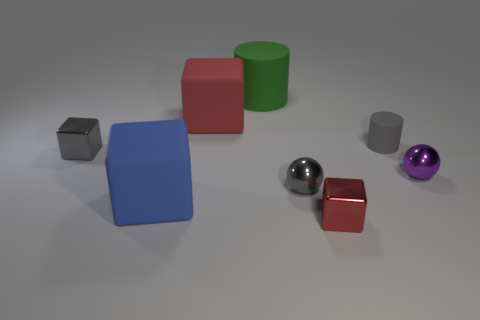Is there any other thing that has the same color as the small rubber cylinder?
Your answer should be very brief. Yes. What shape is the green object that is made of the same material as the blue cube?
Give a very brief answer. Cylinder. What size is the gray metal thing that is right of the blue rubber object?
Your answer should be compact. Small. What is the shape of the green matte object?
Provide a short and direct response. Cylinder. Does the green thing that is to the right of the large blue block have the same size as the gray thing that is in front of the small purple metallic thing?
Your answer should be compact. No. There is a rubber cylinder to the left of the gray cylinder right of the metallic cube on the left side of the small gray sphere; what is its size?
Give a very brief answer. Large. There is a gray metal object on the left side of the gray thing in front of the metal ball that is on the right side of the gray matte thing; what is its shape?
Offer a very short reply. Cube. There is a small gray metallic object behind the small gray metallic sphere; what is its shape?
Offer a terse response. Cube. Is the material of the tiny cylinder the same as the red cube on the left side of the green object?
Keep it short and to the point. Yes. What number of other things are there of the same shape as the green rubber object?
Ensure brevity in your answer.  1. 